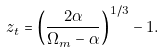Convert formula to latex. <formula><loc_0><loc_0><loc_500><loc_500>z _ { t } = \left ( \frac { 2 \alpha } { \Omega _ { m } - \alpha } \right ) ^ { 1 / 3 } - 1 .</formula> 